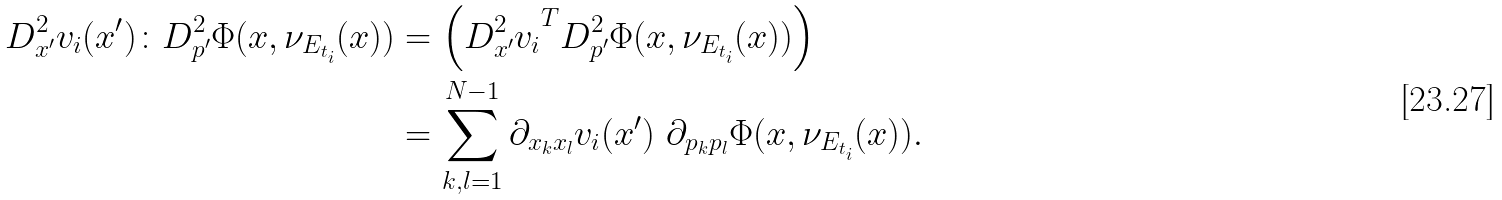<formula> <loc_0><loc_0><loc_500><loc_500>D ^ { 2 } _ { x ^ { \prime } } v _ { i } ( { x } ^ { \prime } ) \colon D ^ { 2 } _ { p ^ { \prime } } \Phi ( { x } , \nu _ { E _ { t _ { i } } } ( { x } ) ) & = \left ( { D ^ { 2 } _ { x ^ { \prime } } v _ { i } } ^ { T } D ^ { 2 } _ { p ^ { \prime } } \Phi ( { x } , \nu _ { E _ { t _ { i } } } ( { x } ) ) \right ) \\ & = \sum _ { k , l = 1 } ^ { N - 1 } \partial _ { x _ { k } x _ { l } } v _ { i } ( { x } ^ { \prime } ) \ \partial _ { p _ { k } p _ { l } } \Phi ( { x } , \nu _ { E _ { t _ { i } } } ( { x } ) ) .</formula> 